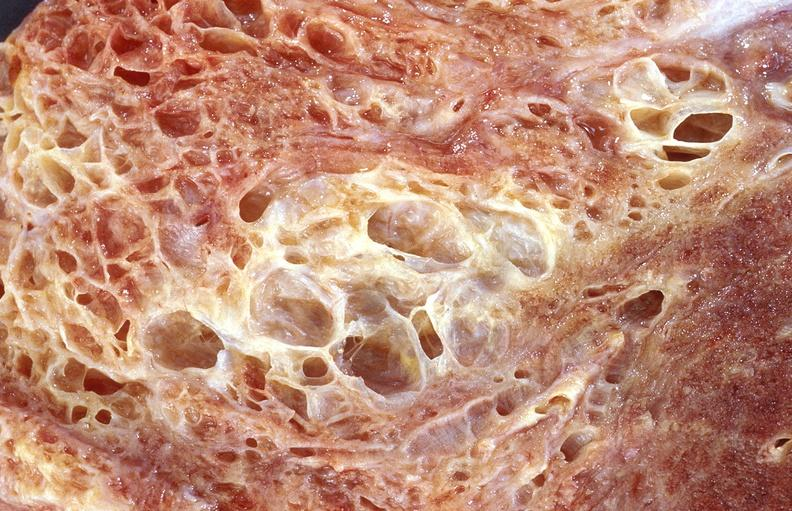what does this image show?
Answer the question using a single word or phrase. Lung fibrosis 